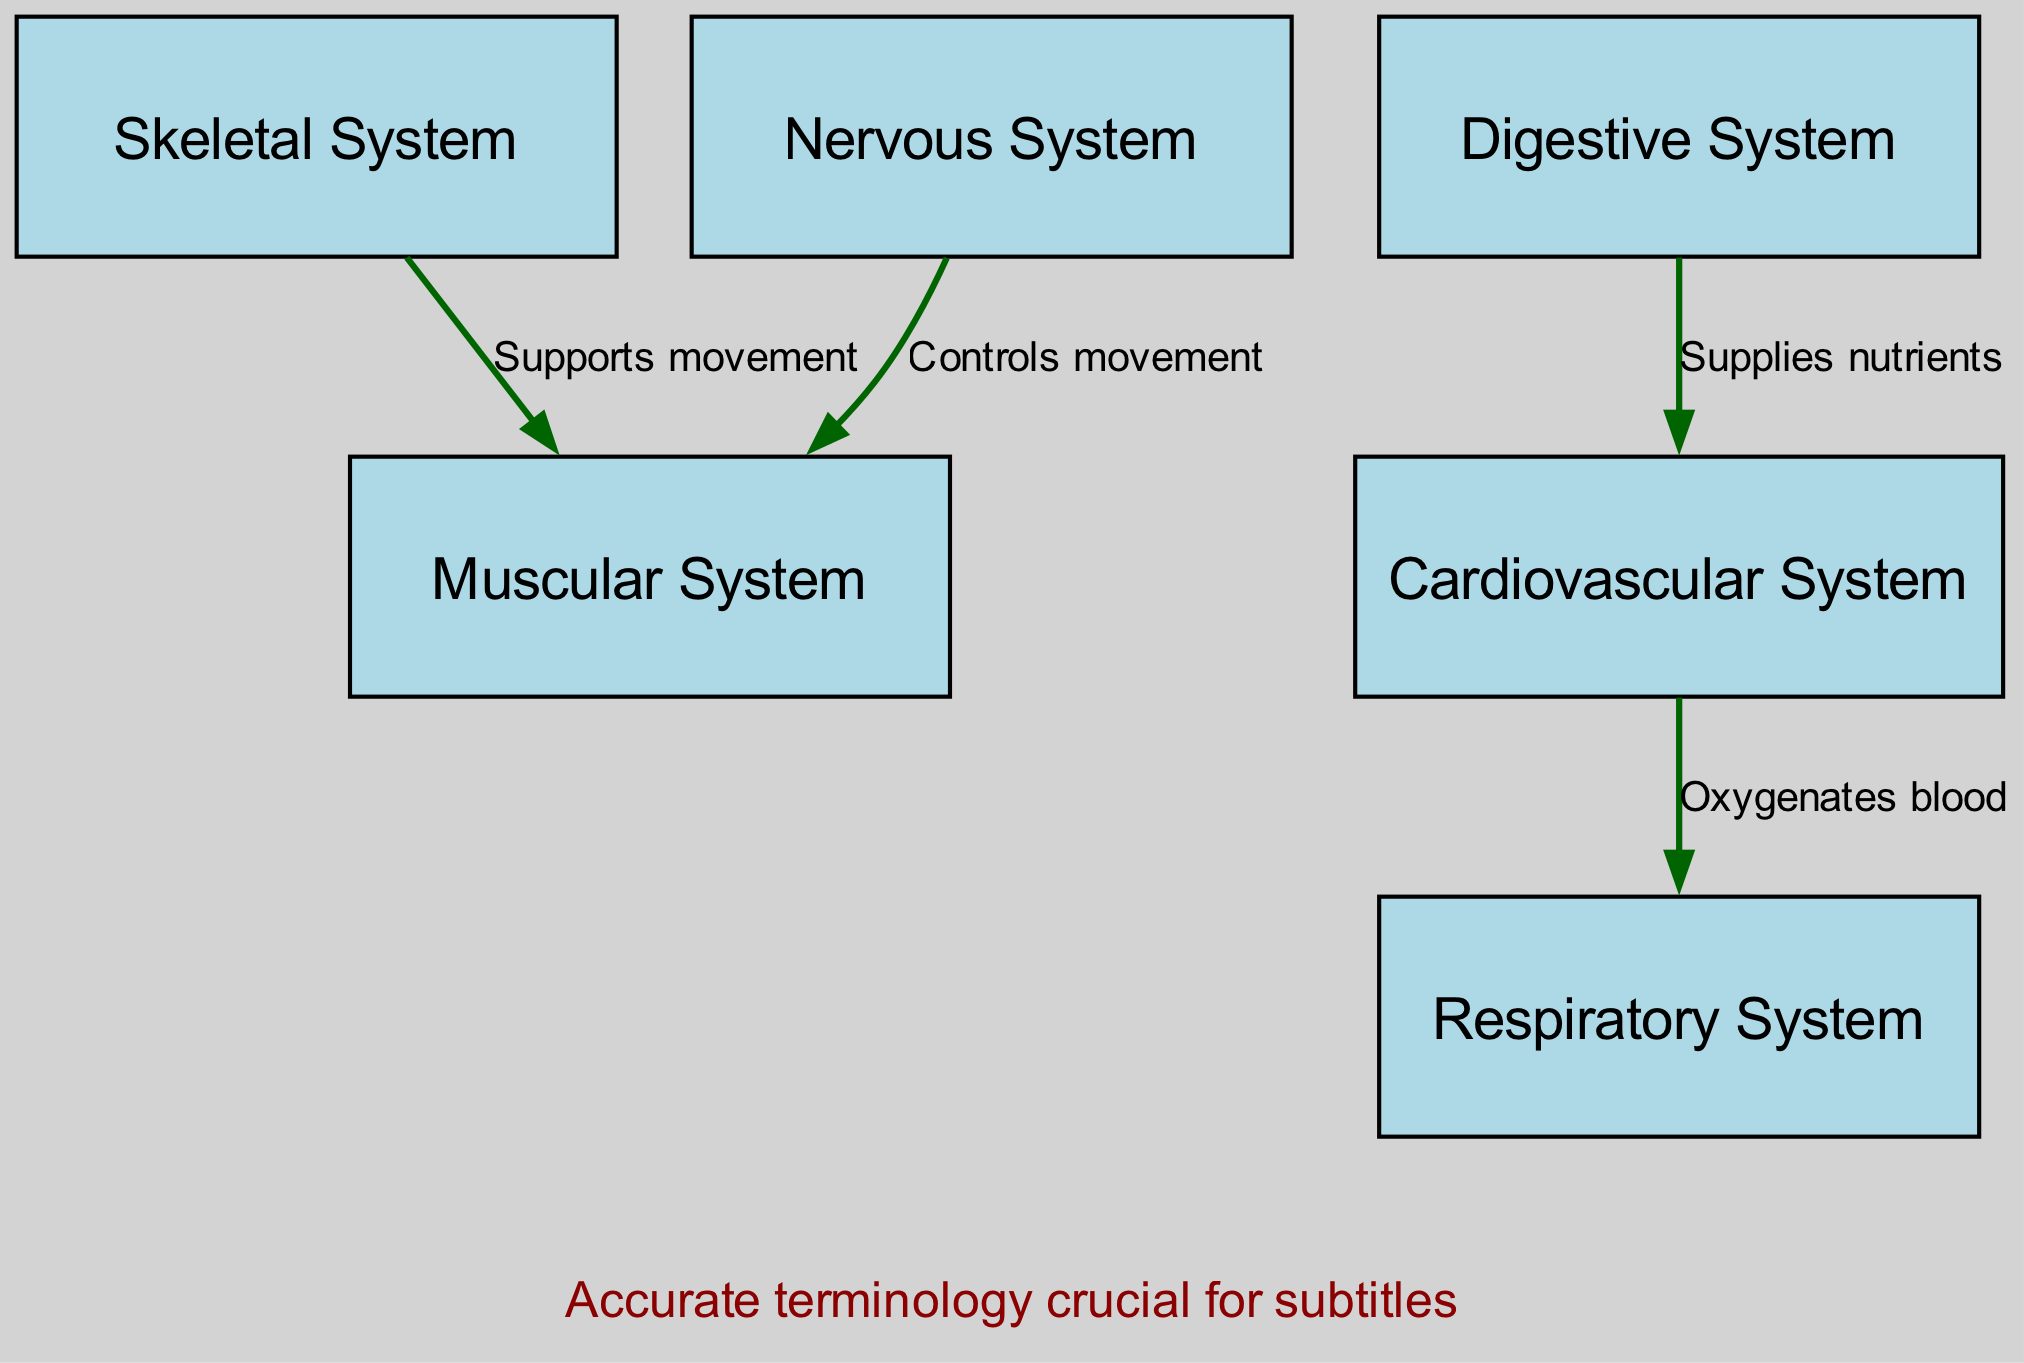What body system is responsible for supporting movement? The label for the node "Skeletal System" clearly indicates that it is responsible for supporting movement, based on the direct connection to the Muscular System that shows this relationship.
Answer: Skeletal System How many body systems are labeled in the diagram? By counting the nodes listed in the data, there are six distinct body systems shown: Skeletal System, Muscular System, Nervous System, Cardiovascular System, Respiratory System, and Digestive System.
Answer: 6 What relationship connects the Nervous System and the Muscular System? The edge connecting the Nervous System to the Muscular System is labeled "Controls movement," which describes the functional relationship between these two systems in the context of human anatomy.
Answer: Controls movement Which system oxygenates the blood? The edge connecting the Cardiovascular System to the Respiratory System is explicitly labeled as "Oxygenates blood," indicating its function in this physiological process.
Answer: Cardiovascular System What does the Digestive System supply to the Cardiovascular System? The edge from the Digestive System to the Cardiovascular System states "Supplies nutrients," specifically indicating the role of the digestive processes in providing essential materials to the blood circulation system.
Answer: Supplies nutrients Which system directly supports the Muscular System? The link from the Skeletal System to the Muscular System is labeled "Supports movement," indicating that the skeletal structure underpins the functionality and movement capabilities of the muscular system.
Answer: Skeletal System What is the purpose of the label at the top of the diagram? The top label states, "Key Body Systems for Medical Narration," which summarizes the overarching theme and reason for displaying these body systems and their interactions in the diagram.
Answer: Key Body Systems for Medical Narration How does the Cardiovascular System interact with the Respiratory System? The edge labeled "Oxygenates blood" reflects the functional interaction between these two systems, where the cardiovascular system relies on the respiratory system to provide oxygen for the blood.
Answer: Oxygenates blood 